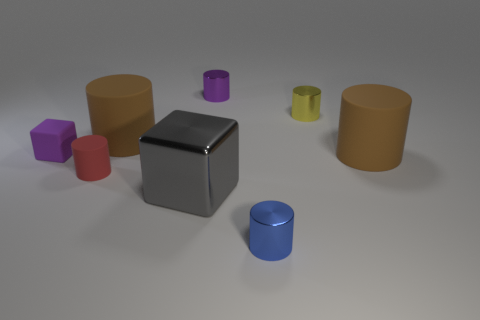Subtract all yellow cylinders. How many cylinders are left? 5 Subtract all red cylinders. How many cylinders are left? 5 Subtract all red cylinders. Subtract all yellow blocks. How many cylinders are left? 5 Add 2 large gray metallic cubes. How many objects exist? 10 Subtract all blocks. How many objects are left? 6 Add 3 matte cylinders. How many matte cylinders are left? 6 Add 3 purple matte things. How many purple matte things exist? 4 Subtract 1 red cylinders. How many objects are left? 7 Subtract all tiny yellow metallic cylinders. Subtract all red rubber cylinders. How many objects are left? 6 